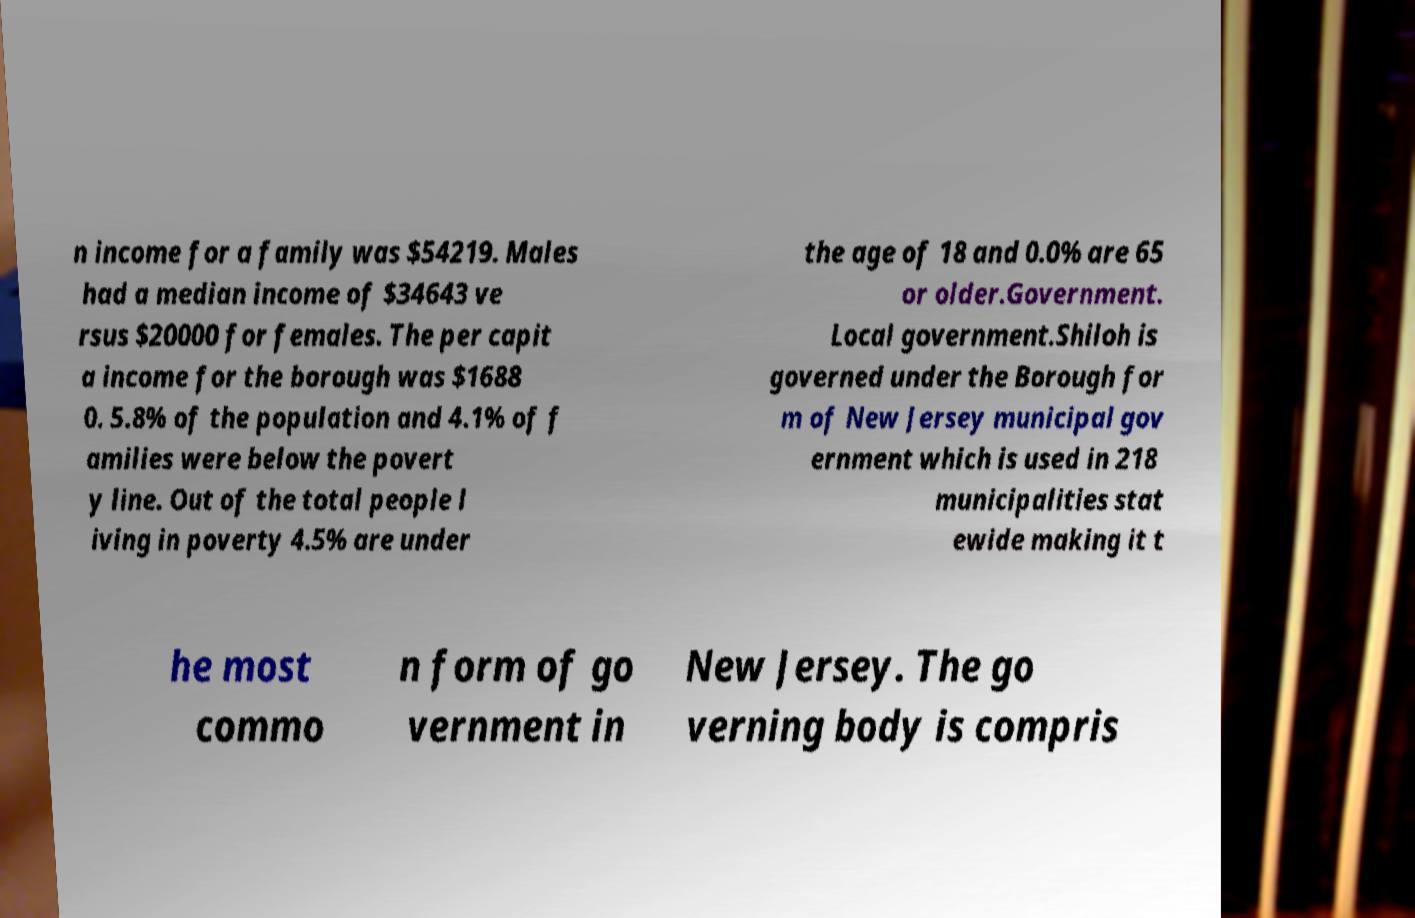Can you accurately transcribe the text from the provided image for me? n income for a family was $54219. Males had a median income of $34643 ve rsus $20000 for females. The per capit a income for the borough was $1688 0. 5.8% of the population and 4.1% of f amilies were below the povert y line. Out of the total people l iving in poverty 4.5% are under the age of 18 and 0.0% are 65 or older.Government. Local government.Shiloh is governed under the Borough for m of New Jersey municipal gov ernment which is used in 218 municipalities stat ewide making it t he most commo n form of go vernment in New Jersey. The go verning body is compris 